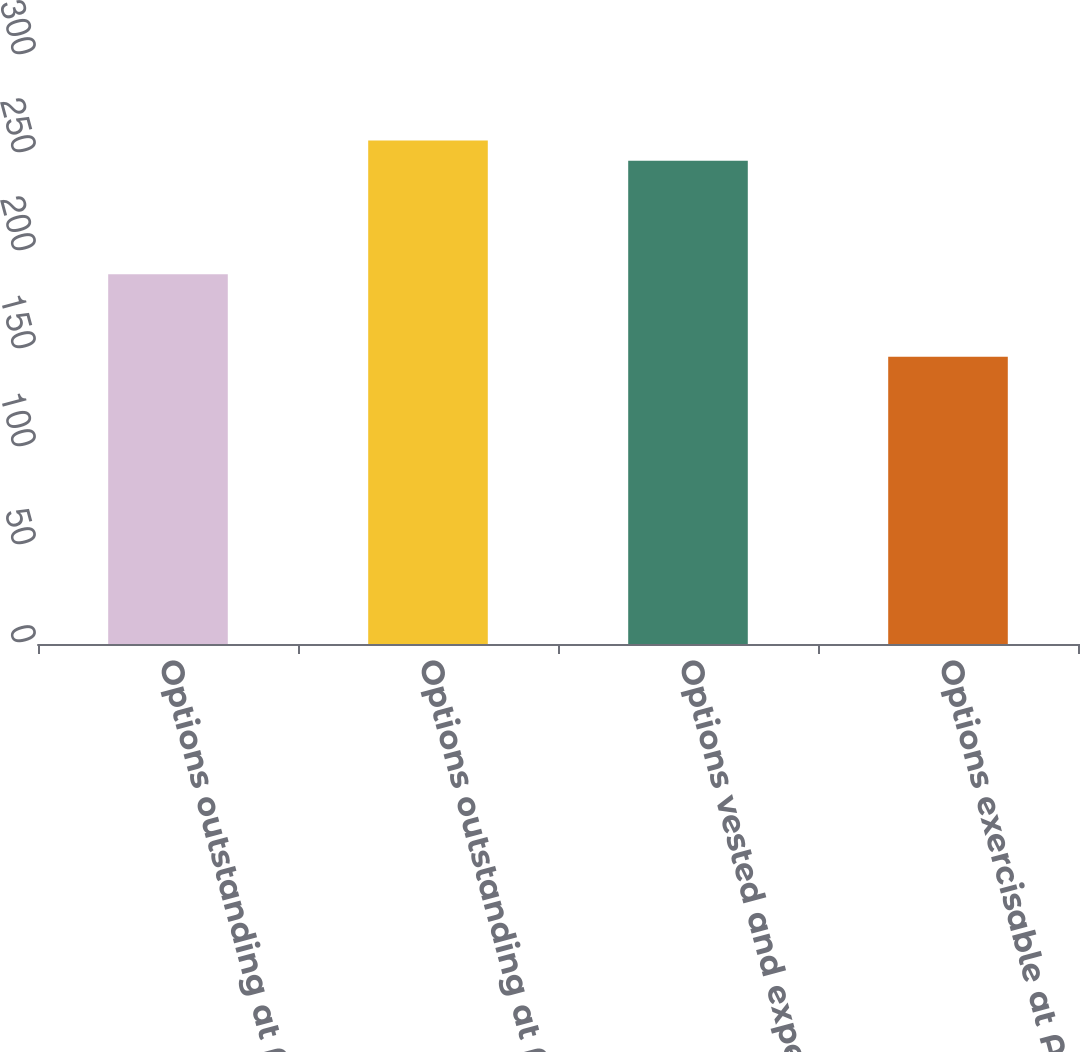<chart> <loc_0><loc_0><loc_500><loc_500><bar_chart><fcel>Options outstanding at April 3<fcel>Options outstanding at April 2<fcel>Options vested and expected to<fcel>Options exercisable at April 2<nl><fcel>188.6<fcel>256.85<fcel>246.5<fcel>146.5<nl></chart> 